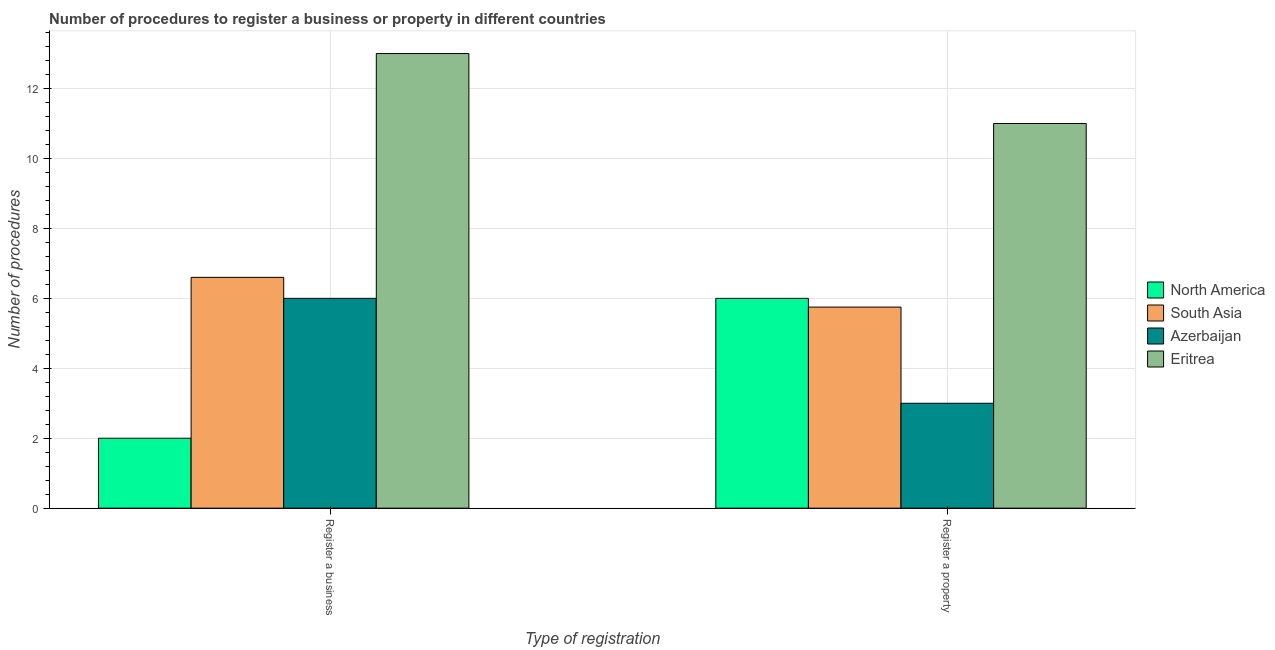How many different coloured bars are there?
Provide a succinct answer. 4. How many groups of bars are there?
Make the answer very short. 2. Are the number of bars on each tick of the X-axis equal?
Offer a terse response. Yes. How many bars are there on the 2nd tick from the left?
Provide a short and direct response. 4. What is the label of the 2nd group of bars from the left?
Ensure brevity in your answer.  Register a property. What is the number of procedures to register a business in South Asia?
Your response must be concise. 6.6. Across all countries, what is the minimum number of procedures to register a business?
Keep it short and to the point. 2. In which country was the number of procedures to register a property maximum?
Ensure brevity in your answer.  Eritrea. In which country was the number of procedures to register a property minimum?
Provide a succinct answer. Azerbaijan. What is the total number of procedures to register a property in the graph?
Give a very brief answer. 25.75. What is the difference between the number of procedures to register a property in Eritrea and that in North America?
Make the answer very short. 5. What is the difference between the number of procedures to register a business in Eritrea and the number of procedures to register a property in North America?
Keep it short and to the point. 7. What is the average number of procedures to register a business per country?
Your answer should be very brief. 6.9. What is the difference between the number of procedures to register a business and number of procedures to register a property in South Asia?
Offer a terse response. 0.85. What is the ratio of the number of procedures to register a business in Azerbaijan to that in Eritrea?
Your answer should be compact. 0.46. What does the 2nd bar from the left in Register a business represents?
Make the answer very short. South Asia. What is the difference between two consecutive major ticks on the Y-axis?
Your answer should be compact. 2. Does the graph contain any zero values?
Make the answer very short. No. Does the graph contain grids?
Ensure brevity in your answer.  Yes. Where does the legend appear in the graph?
Give a very brief answer. Center right. How many legend labels are there?
Give a very brief answer. 4. How are the legend labels stacked?
Your response must be concise. Vertical. What is the title of the graph?
Your answer should be very brief. Number of procedures to register a business or property in different countries. Does "East Asia (developing only)" appear as one of the legend labels in the graph?
Your answer should be compact. No. What is the label or title of the X-axis?
Offer a terse response. Type of registration. What is the label or title of the Y-axis?
Make the answer very short. Number of procedures. What is the Number of procedures in North America in Register a business?
Give a very brief answer. 2. What is the Number of procedures of Azerbaijan in Register a business?
Provide a succinct answer. 6. What is the Number of procedures in Eritrea in Register a business?
Offer a very short reply. 13. What is the Number of procedures of South Asia in Register a property?
Your response must be concise. 5.75. What is the Number of procedures in Azerbaijan in Register a property?
Provide a short and direct response. 3. What is the Number of procedures of Eritrea in Register a property?
Provide a succinct answer. 11. Across all Type of registration, what is the maximum Number of procedures in North America?
Provide a succinct answer. 6. Across all Type of registration, what is the minimum Number of procedures of North America?
Give a very brief answer. 2. Across all Type of registration, what is the minimum Number of procedures of South Asia?
Make the answer very short. 5.75. Across all Type of registration, what is the minimum Number of procedures of Eritrea?
Keep it short and to the point. 11. What is the total Number of procedures in South Asia in the graph?
Provide a succinct answer. 12.35. What is the difference between the Number of procedures in North America in Register a business and that in Register a property?
Offer a very short reply. -4. What is the difference between the Number of procedures in North America in Register a business and the Number of procedures in South Asia in Register a property?
Your answer should be compact. -3.75. What is the difference between the Number of procedures in North America in Register a business and the Number of procedures in Azerbaijan in Register a property?
Keep it short and to the point. -1. What is the difference between the Number of procedures in North America in Register a business and the Number of procedures in Eritrea in Register a property?
Make the answer very short. -9. What is the average Number of procedures of North America per Type of registration?
Offer a terse response. 4. What is the average Number of procedures of South Asia per Type of registration?
Your answer should be very brief. 6.17. What is the average Number of procedures in Eritrea per Type of registration?
Your answer should be very brief. 12. What is the difference between the Number of procedures of North America and Number of procedures of South Asia in Register a business?
Ensure brevity in your answer.  -4.6. What is the difference between the Number of procedures of North America and Number of procedures of Azerbaijan in Register a business?
Provide a short and direct response. -4. What is the difference between the Number of procedures of South Asia and Number of procedures of Eritrea in Register a business?
Your answer should be compact. -6.4. What is the difference between the Number of procedures of Azerbaijan and Number of procedures of Eritrea in Register a business?
Offer a very short reply. -7. What is the difference between the Number of procedures of North America and Number of procedures of Azerbaijan in Register a property?
Provide a short and direct response. 3. What is the difference between the Number of procedures of South Asia and Number of procedures of Azerbaijan in Register a property?
Give a very brief answer. 2.75. What is the difference between the Number of procedures in South Asia and Number of procedures in Eritrea in Register a property?
Offer a very short reply. -5.25. What is the ratio of the Number of procedures of North America in Register a business to that in Register a property?
Give a very brief answer. 0.33. What is the ratio of the Number of procedures in South Asia in Register a business to that in Register a property?
Keep it short and to the point. 1.15. What is the ratio of the Number of procedures in Azerbaijan in Register a business to that in Register a property?
Offer a terse response. 2. What is the ratio of the Number of procedures in Eritrea in Register a business to that in Register a property?
Your answer should be compact. 1.18. What is the difference between the highest and the second highest Number of procedures of South Asia?
Your answer should be compact. 0.85. What is the difference between the highest and the second highest Number of procedures in Azerbaijan?
Your answer should be compact. 3. What is the difference between the highest and the lowest Number of procedures of North America?
Make the answer very short. 4. What is the difference between the highest and the lowest Number of procedures in South Asia?
Provide a succinct answer. 0.85. 